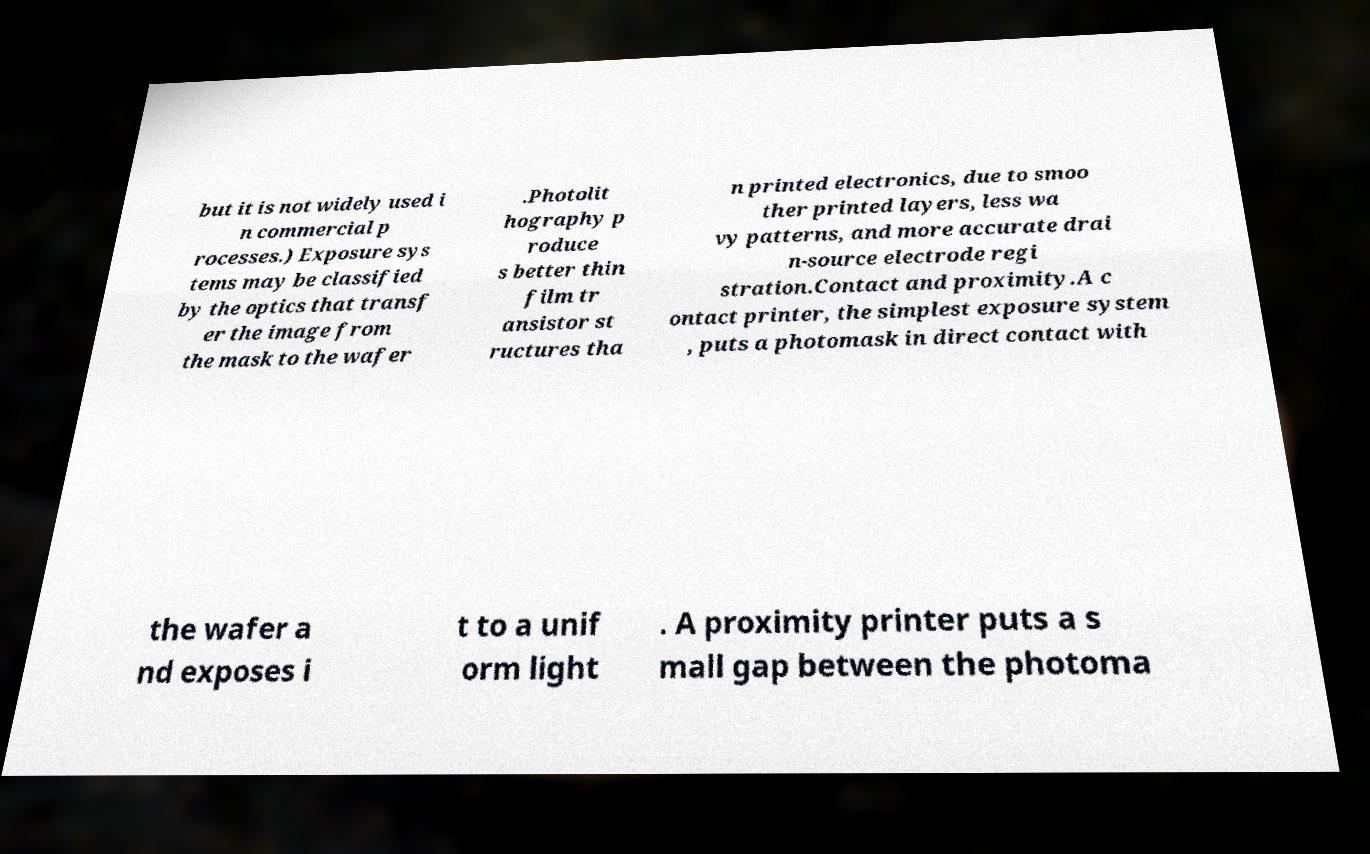For documentation purposes, I need the text within this image transcribed. Could you provide that? but it is not widely used i n commercial p rocesses.) Exposure sys tems may be classified by the optics that transf er the image from the mask to the wafer .Photolit hography p roduce s better thin film tr ansistor st ructures tha n printed electronics, due to smoo ther printed layers, less wa vy patterns, and more accurate drai n-source electrode regi stration.Contact and proximity.A c ontact printer, the simplest exposure system , puts a photomask in direct contact with the wafer a nd exposes i t to a unif orm light . A proximity printer puts a s mall gap between the photoma 